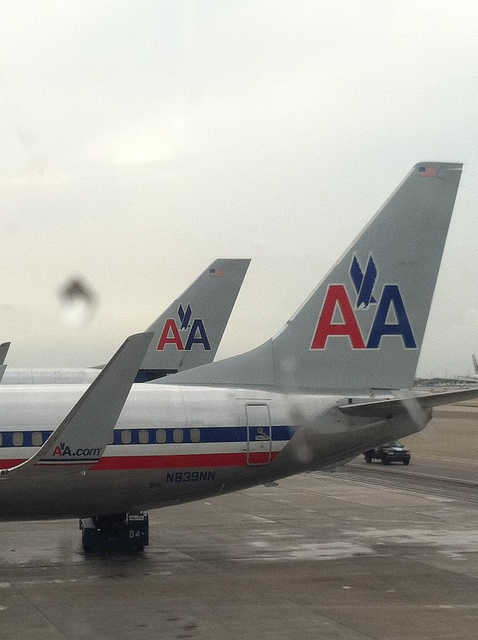Describe the objects in this image and their specific colors. I can see airplane in white, gray, black, darkgray, and maroon tones, airplane in ivory, gray, darkgray, lightgray, and black tones, and car in ivory, black, gray, and darkgray tones in this image. 